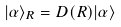Convert formula to latex. <formula><loc_0><loc_0><loc_500><loc_500>| \alpha \rangle _ { R } = D ( R ) | \alpha \rangle</formula> 